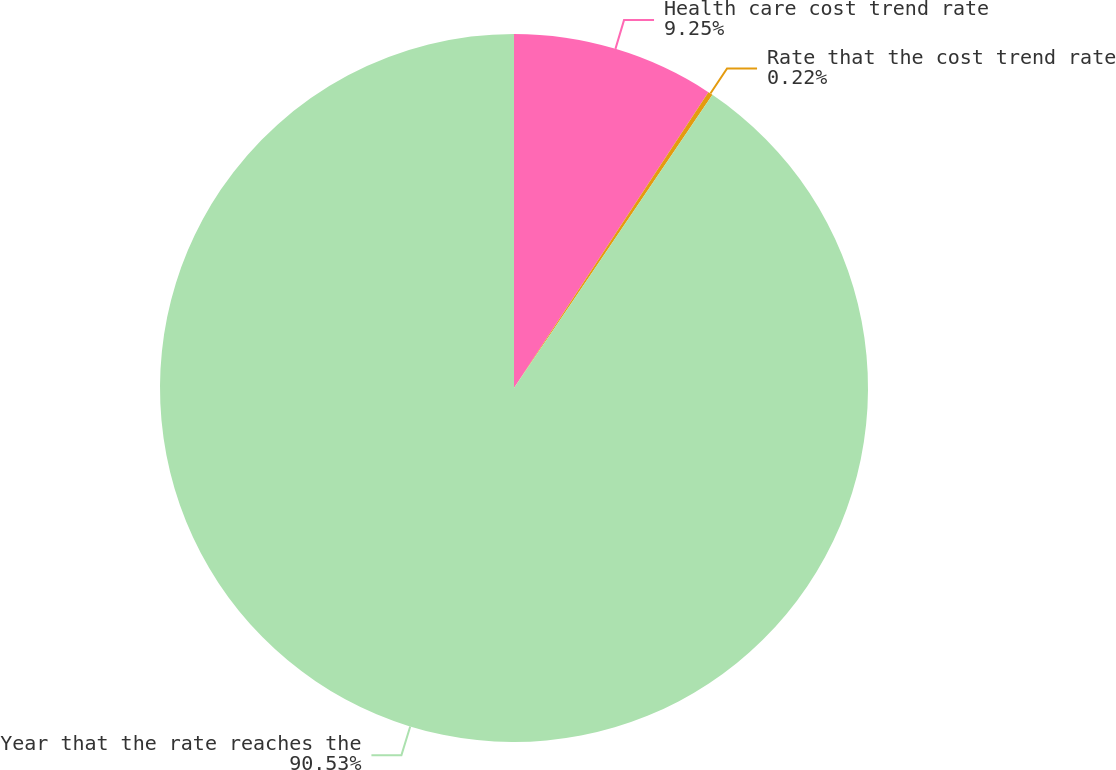<chart> <loc_0><loc_0><loc_500><loc_500><pie_chart><fcel>Health care cost trend rate<fcel>Rate that the cost trend rate<fcel>Year that the rate reaches the<nl><fcel>9.25%<fcel>0.22%<fcel>90.52%<nl></chart> 